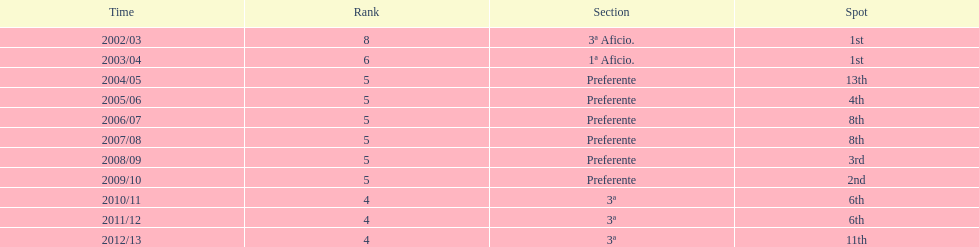What place was 1a aficio and 3a aficio? 1st. 